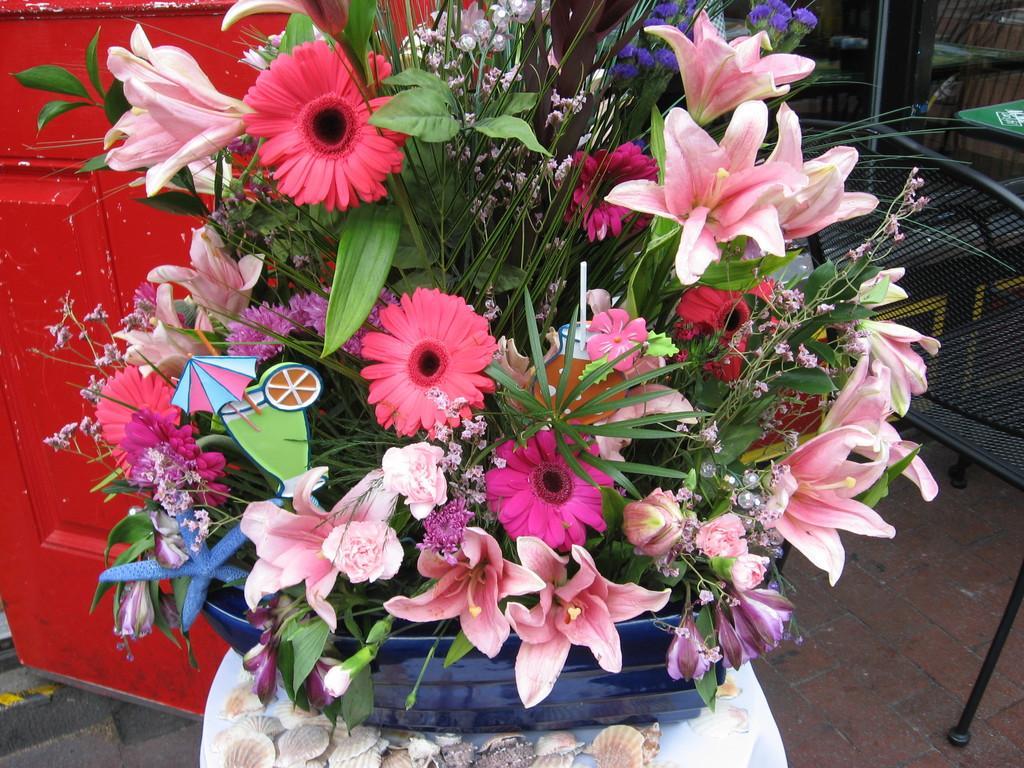How would you summarize this image in a sentence or two? In front of the image there is a flower pot with flowers and leaves in it, behind the flower pot there is an object and there is a chair, behind the chair there are chairs, tables, metal rod. 